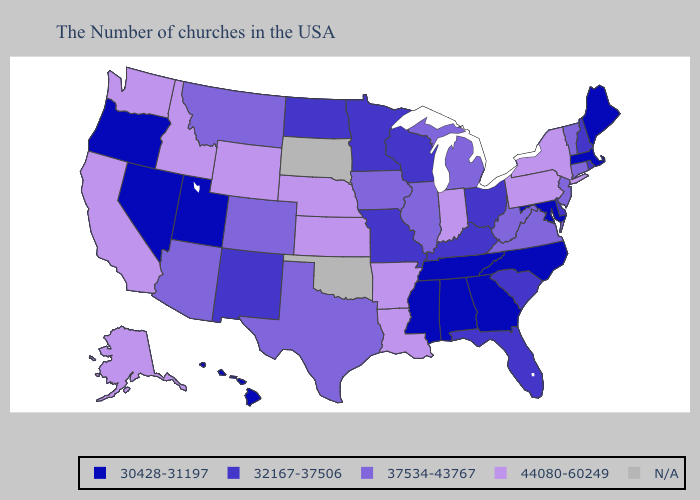What is the value of Delaware?
Write a very short answer. 32167-37506. Does Alabama have the highest value in the South?
Be succinct. No. Among the states that border Oregon , does California have the highest value?
Keep it brief. Yes. What is the lowest value in the MidWest?
Answer briefly. 32167-37506. Which states have the highest value in the USA?
Concise answer only. New York, Pennsylvania, Indiana, Louisiana, Arkansas, Kansas, Nebraska, Wyoming, Idaho, California, Washington, Alaska. What is the value of Alaska?
Write a very short answer. 44080-60249. Name the states that have a value in the range 30428-31197?
Short answer required. Maine, Massachusetts, Maryland, North Carolina, Georgia, Alabama, Tennessee, Mississippi, Utah, Nevada, Oregon, Hawaii. What is the value of Wisconsin?
Short answer required. 32167-37506. Does Wyoming have the highest value in the USA?
Be succinct. Yes. Name the states that have a value in the range 30428-31197?
Answer briefly. Maine, Massachusetts, Maryland, North Carolina, Georgia, Alabama, Tennessee, Mississippi, Utah, Nevada, Oregon, Hawaii. Does Arizona have the lowest value in the USA?
Be succinct. No. What is the highest value in states that border Arizona?
Write a very short answer. 44080-60249. What is the highest value in the USA?
Give a very brief answer. 44080-60249. 